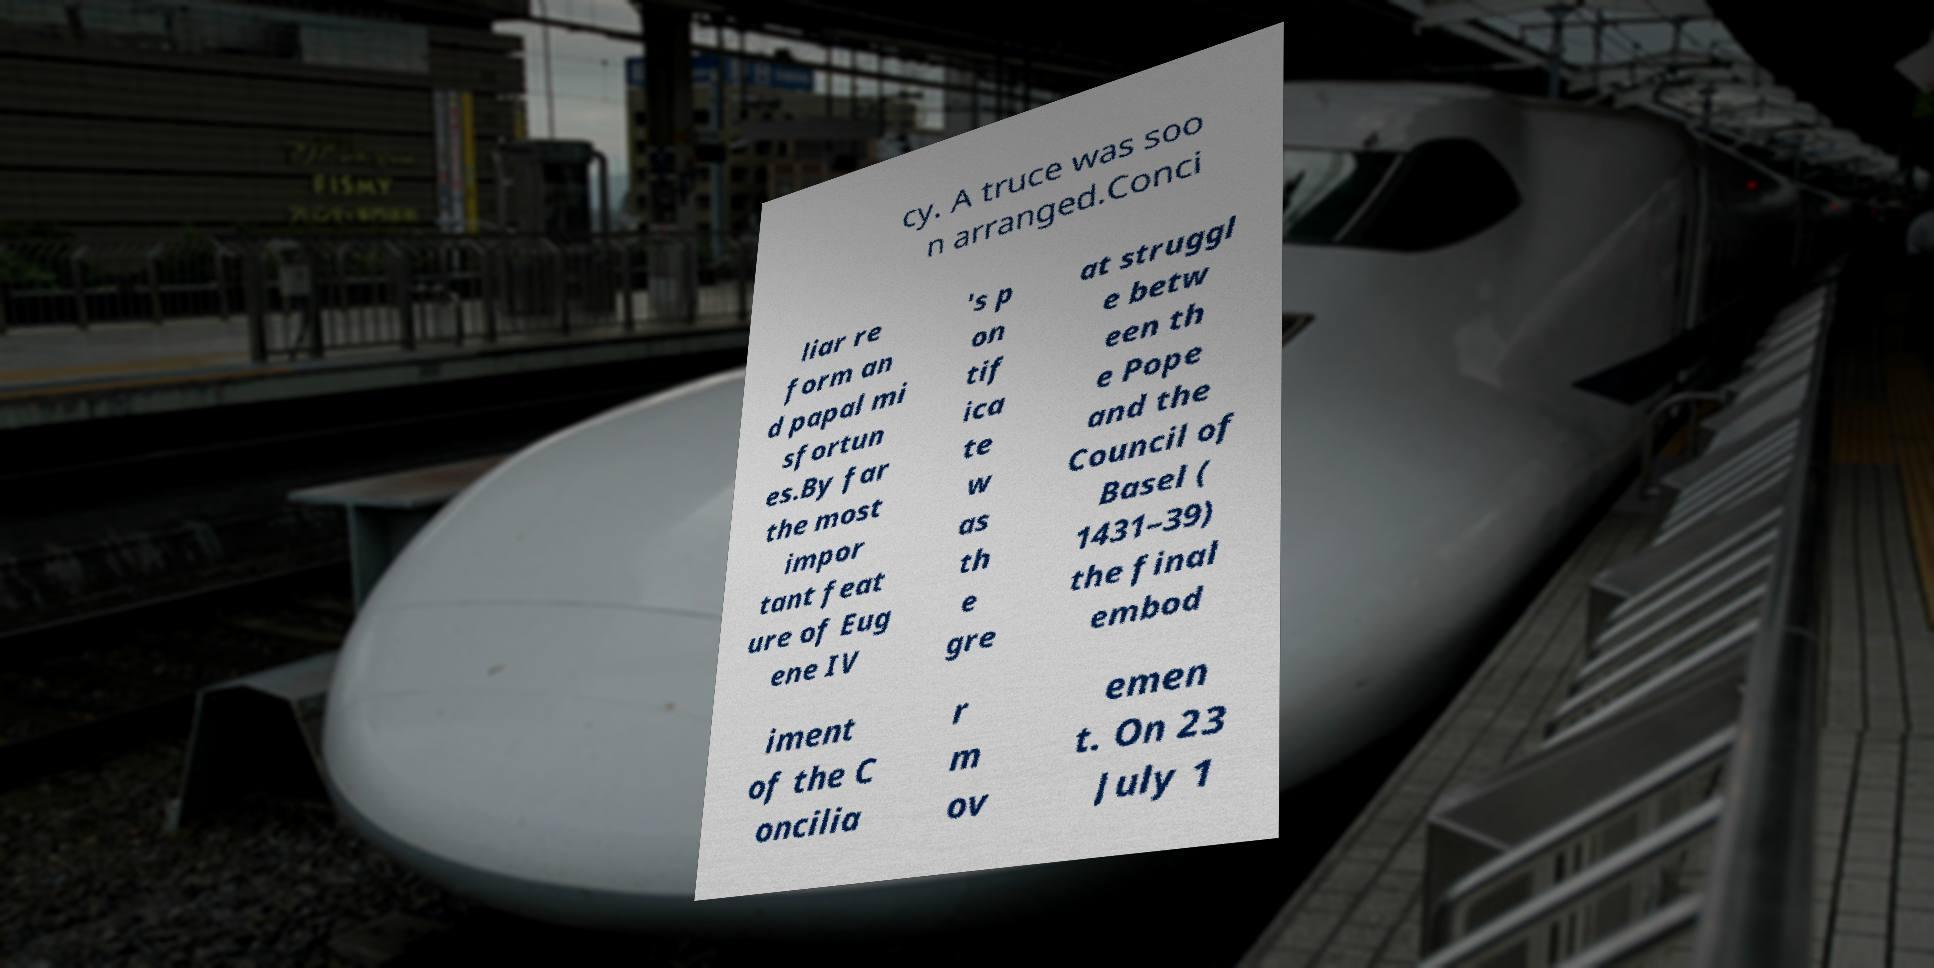Can you read and provide the text displayed in the image?This photo seems to have some interesting text. Can you extract and type it out for me? cy. A truce was soo n arranged.Conci liar re form an d papal mi sfortun es.By far the most impor tant feat ure of Eug ene IV 's p on tif ica te w as th e gre at struggl e betw een th e Pope and the Council of Basel ( 1431–39) the final embod iment of the C oncilia r m ov emen t. On 23 July 1 